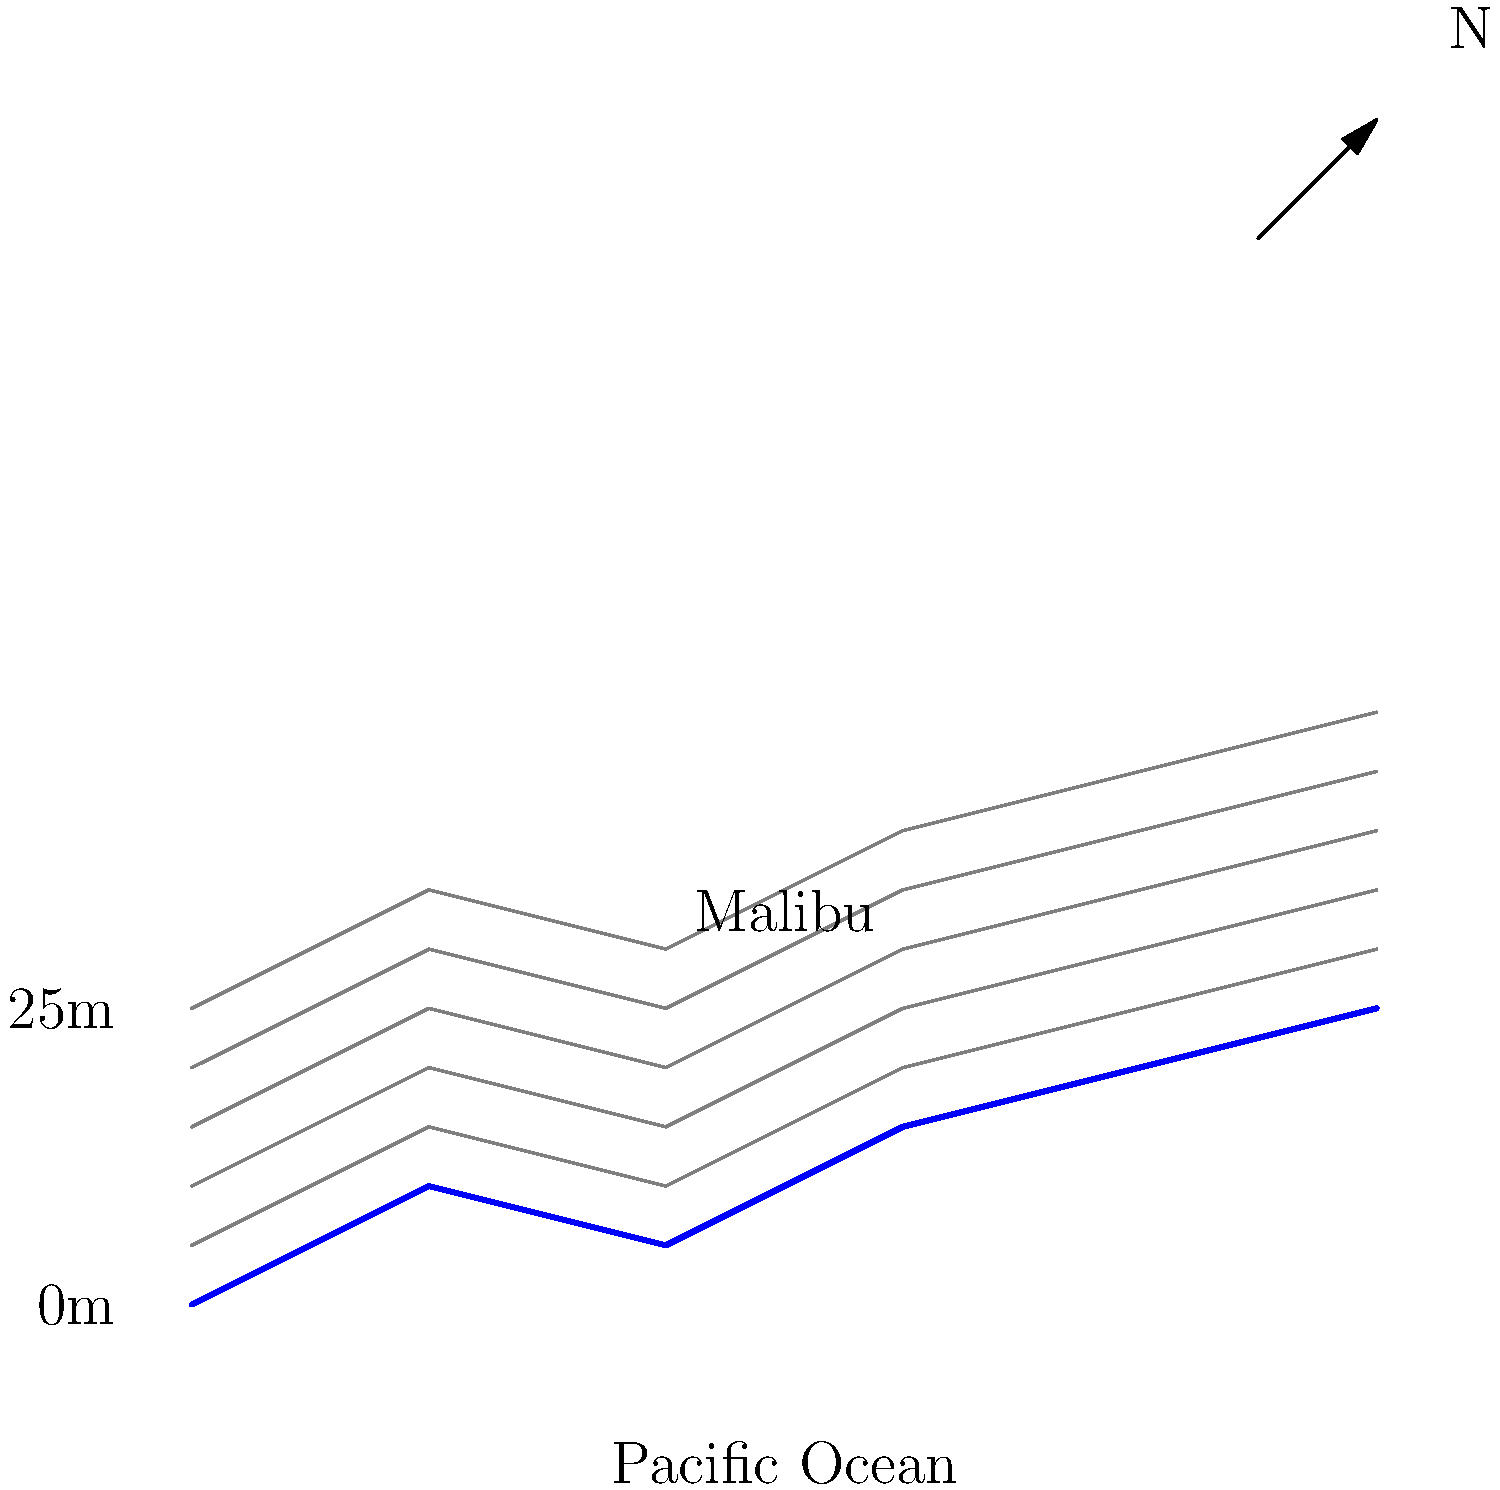Based on the topographic map of Malibu's coastline, what is the approximate elevation of the highest point shown on land? To determine the highest elevation shown on the topographic map, we need to follow these steps:

1. Observe that the map shows contour lines, which represent equal elevations above sea level.
2. Note that the coastline is represented by the lowermost blue line, which corresponds to sea level (0m elevation).
3. Count the number of contour lines above the coastline. Each contour line represents an increase in elevation.
4. We can see that there are 5 distinct contour lines above the coastline.
5. The vertical scale on the left side of the map shows that the distance between each contour line is 5 meters.
6. Therefore, we can calculate the highest elevation by multiplying the number of contour lines by the elevation difference between each line:

   $5 \text{ contour lines} \times 5 \text{ meters} = 25 \text{ meters}$

7. This is confirmed by the elevation label on the left side of the map, which shows "25m" at the top.

Thus, the highest point shown on land in this topographic map of Malibu's coastline is approximately 25 meters above sea level.
Answer: 25 meters 